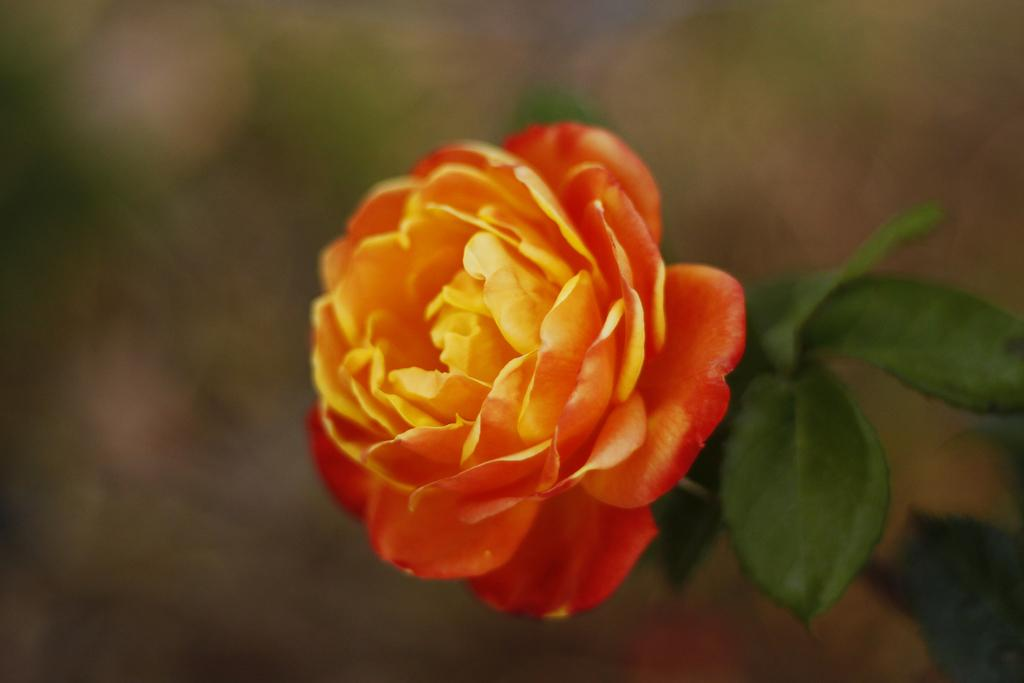What is the main subject of the image? There is a flower in the image. Is the flower part of a larger plant? Yes, the flower is attached to a plant. How would you describe the background of the image? The background of the image is blurred. What type of order can be seen being placed in the image? There is no order being placed in the image; it features a flower attached to a plant with a blurred background. 